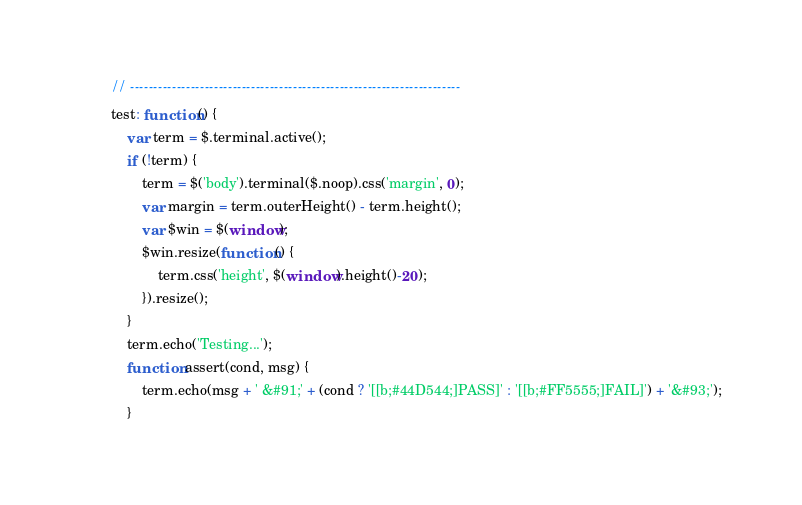Convert code to text. <code><loc_0><loc_0><loc_500><loc_500><_JavaScript_>        // -----------------------------------------------------------------------
        test: function() {
            var term = $.terminal.active();
            if (!term) {
                term = $('body').terminal($.noop).css('margin', 0);
                var margin = term.outerHeight() - term.height();
                var $win = $(window);
                $win.resize(function() {
                    term.css('height', $(window).height()-20);
                }).resize();
            }
            term.echo('Testing...');
            function assert(cond, msg) {
                term.echo(msg + ' &#91;' + (cond ? '[[b;#44D544;]PASS]' : '[[b;#FF5555;]FAIL]') + '&#93;');
            }</code> 